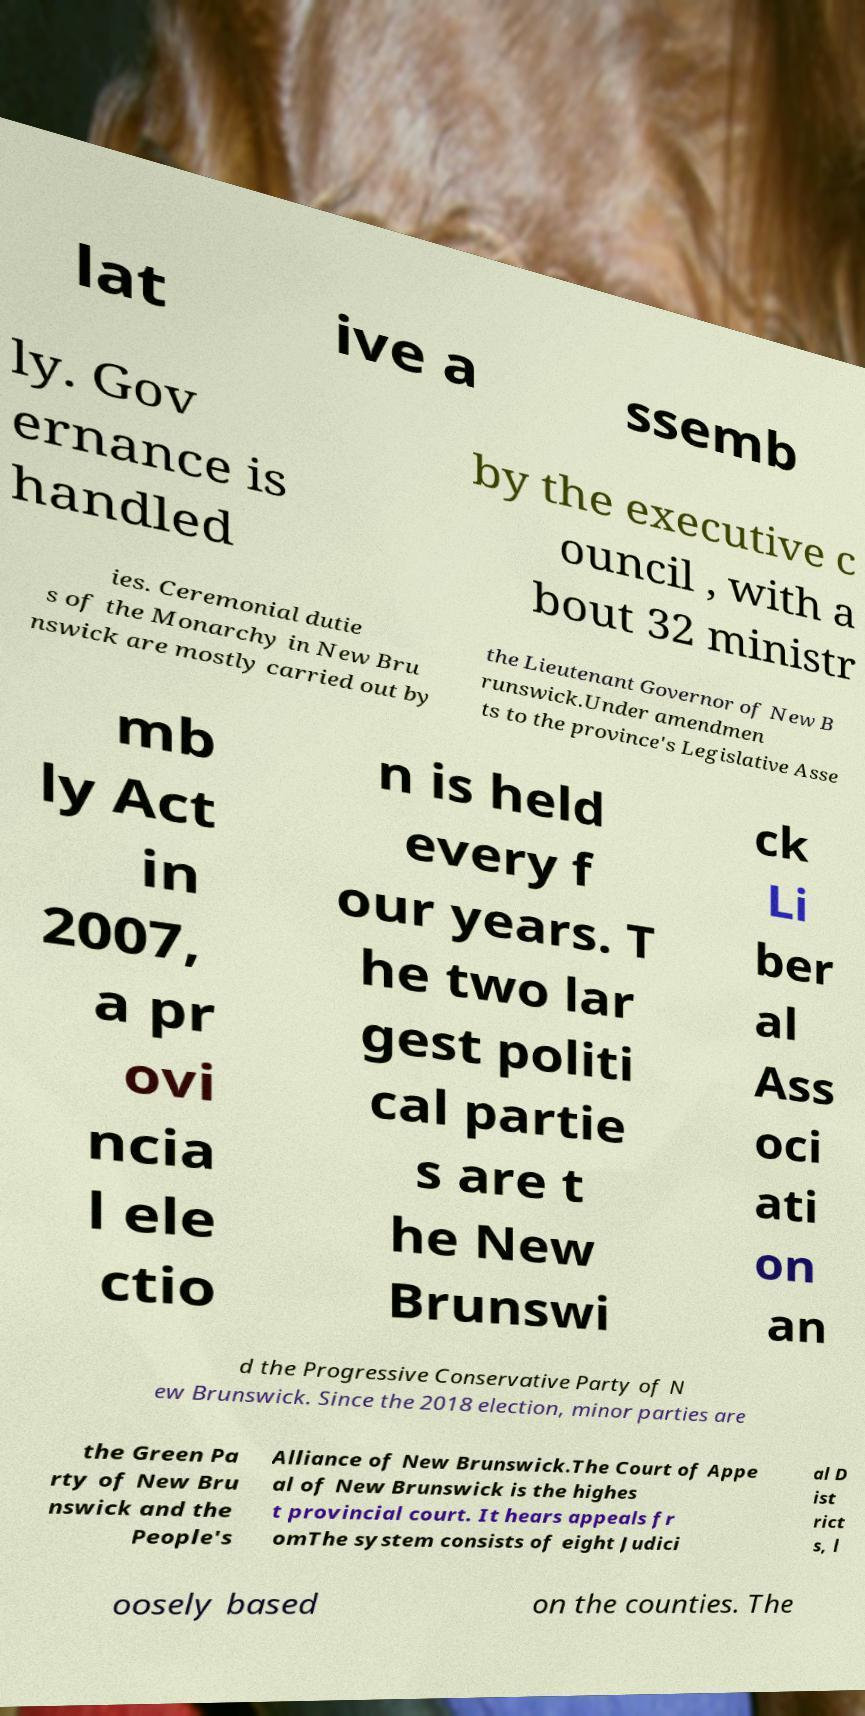For documentation purposes, I need the text within this image transcribed. Could you provide that? lat ive a ssemb ly. Gov ernance is handled by the executive c ouncil , with a bout 32 ministr ies. Ceremonial dutie s of the Monarchy in New Bru nswick are mostly carried out by the Lieutenant Governor of New B runswick.Under amendmen ts to the province's Legislative Asse mb ly Act in 2007, a pr ovi ncia l ele ctio n is held every f our years. T he two lar gest politi cal partie s are t he New Brunswi ck Li ber al Ass oci ati on an d the Progressive Conservative Party of N ew Brunswick. Since the 2018 election, minor parties are the Green Pa rty of New Bru nswick and the People's Alliance of New Brunswick.The Court of Appe al of New Brunswick is the highes t provincial court. It hears appeals fr omThe system consists of eight Judici al D ist rict s, l oosely based on the counties. The 